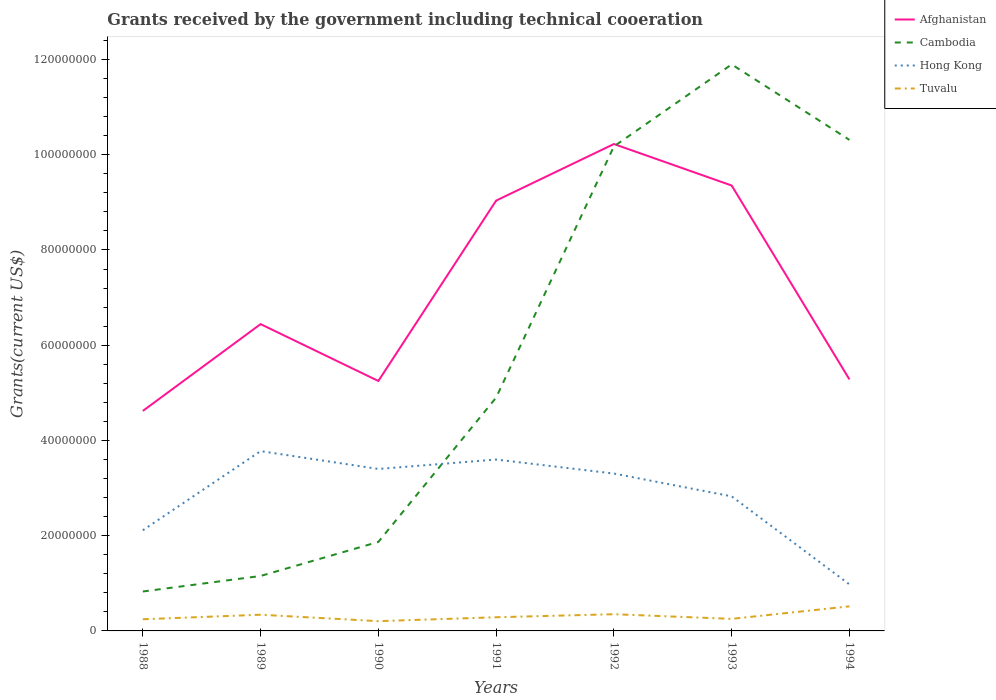How many different coloured lines are there?
Your response must be concise. 4. Does the line corresponding to Cambodia intersect with the line corresponding to Hong Kong?
Give a very brief answer. Yes. Across all years, what is the maximum total grants received by the government in Tuvalu?
Provide a short and direct response. 2.05e+06. What is the total total grants received by the government in Tuvalu in the graph?
Ensure brevity in your answer.  9.80e+05. What is the difference between the highest and the second highest total grants received by the government in Cambodia?
Your answer should be compact. 1.11e+08. Is the total grants received by the government in Tuvalu strictly greater than the total grants received by the government in Cambodia over the years?
Your response must be concise. Yes. How many lines are there?
Your answer should be compact. 4. Are the values on the major ticks of Y-axis written in scientific E-notation?
Offer a terse response. No. Where does the legend appear in the graph?
Give a very brief answer. Top right. How are the legend labels stacked?
Make the answer very short. Vertical. What is the title of the graph?
Offer a terse response. Grants received by the government including technical cooeration. Does "Oman" appear as one of the legend labels in the graph?
Your answer should be compact. No. What is the label or title of the Y-axis?
Ensure brevity in your answer.  Grants(current US$). What is the Grants(current US$) in Afghanistan in 1988?
Your answer should be very brief. 4.62e+07. What is the Grants(current US$) of Cambodia in 1988?
Offer a terse response. 8.28e+06. What is the Grants(current US$) in Hong Kong in 1988?
Your response must be concise. 2.11e+07. What is the Grants(current US$) in Tuvalu in 1988?
Give a very brief answer. 2.45e+06. What is the Grants(current US$) in Afghanistan in 1989?
Your response must be concise. 6.44e+07. What is the Grants(current US$) of Cambodia in 1989?
Give a very brief answer. 1.15e+07. What is the Grants(current US$) of Hong Kong in 1989?
Your answer should be compact. 3.78e+07. What is the Grants(current US$) in Tuvalu in 1989?
Provide a short and direct response. 3.40e+06. What is the Grants(current US$) of Afghanistan in 1990?
Give a very brief answer. 5.25e+07. What is the Grants(current US$) of Cambodia in 1990?
Provide a succinct answer. 1.87e+07. What is the Grants(current US$) of Hong Kong in 1990?
Offer a terse response. 3.40e+07. What is the Grants(current US$) of Tuvalu in 1990?
Offer a very short reply. 2.05e+06. What is the Grants(current US$) in Afghanistan in 1991?
Provide a succinct answer. 9.04e+07. What is the Grants(current US$) of Cambodia in 1991?
Your response must be concise. 4.90e+07. What is the Grants(current US$) in Hong Kong in 1991?
Provide a succinct answer. 3.60e+07. What is the Grants(current US$) of Tuvalu in 1991?
Your response must be concise. 2.87e+06. What is the Grants(current US$) in Afghanistan in 1992?
Give a very brief answer. 1.02e+08. What is the Grants(current US$) of Cambodia in 1992?
Give a very brief answer. 1.02e+08. What is the Grants(current US$) in Hong Kong in 1992?
Provide a short and direct response. 3.30e+07. What is the Grants(current US$) in Tuvalu in 1992?
Your response must be concise. 3.51e+06. What is the Grants(current US$) of Afghanistan in 1993?
Provide a short and direct response. 9.35e+07. What is the Grants(current US$) in Cambodia in 1993?
Your answer should be compact. 1.19e+08. What is the Grants(current US$) of Hong Kong in 1993?
Offer a terse response. 2.83e+07. What is the Grants(current US$) of Tuvalu in 1993?
Keep it short and to the point. 2.53e+06. What is the Grants(current US$) of Afghanistan in 1994?
Provide a succinct answer. 5.28e+07. What is the Grants(current US$) in Cambodia in 1994?
Make the answer very short. 1.03e+08. What is the Grants(current US$) in Hong Kong in 1994?
Give a very brief answer. 9.77e+06. What is the Grants(current US$) of Tuvalu in 1994?
Offer a very short reply. 5.16e+06. Across all years, what is the maximum Grants(current US$) of Afghanistan?
Your answer should be very brief. 1.02e+08. Across all years, what is the maximum Grants(current US$) of Cambodia?
Your response must be concise. 1.19e+08. Across all years, what is the maximum Grants(current US$) in Hong Kong?
Your answer should be compact. 3.78e+07. Across all years, what is the maximum Grants(current US$) in Tuvalu?
Your answer should be very brief. 5.16e+06. Across all years, what is the minimum Grants(current US$) of Afghanistan?
Provide a succinct answer. 4.62e+07. Across all years, what is the minimum Grants(current US$) in Cambodia?
Make the answer very short. 8.28e+06. Across all years, what is the minimum Grants(current US$) in Hong Kong?
Give a very brief answer. 9.77e+06. Across all years, what is the minimum Grants(current US$) of Tuvalu?
Your answer should be very brief. 2.05e+06. What is the total Grants(current US$) in Afghanistan in the graph?
Your answer should be compact. 5.02e+08. What is the total Grants(current US$) in Cambodia in the graph?
Your response must be concise. 4.11e+08. What is the total Grants(current US$) of Hong Kong in the graph?
Your answer should be very brief. 2.00e+08. What is the total Grants(current US$) of Tuvalu in the graph?
Your answer should be compact. 2.20e+07. What is the difference between the Grants(current US$) in Afghanistan in 1988 and that in 1989?
Keep it short and to the point. -1.82e+07. What is the difference between the Grants(current US$) of Cambodia in 1988 and that in 1989?
Offer a terse response. -3.26e+06. What is the difference between the Grants(current US$) of Hong Kong in 1988 and that in 1989?
Offer a very short reply. -1.66e+07. What is the difference between the Grants(current US$) in Tuvalu in 1988 and that in 1989?
Offer a very short reply. -9.50e+05. What is the difference between the Grants(current US$) in Afghanistan in 1988 and that in 1990?
Offer a terse response. -6.29e+06. What is the difference between the Grants(current US$) of Cambodia in 1988 and that in 1990?
Offer a terse response. -1.04e+07. What is the difference between the Grants(current US$) of Hong Kong in 1988 and that in 1990?
Your response must be concise. -1.29e+07. What is the difference between the Grants(current US$) in Tuvalu in 1988 and that in 1990?
Your response must be concise. 4.00e+05. What is the difference between the Grants(current US$) of Afghanistan in 1988 and that in 1991?
Your answer should be very brief. -4.42e+07. What is the difference between the Grants(current US$) of Cambodia in 1988 and that in 1991?
Your response must be concise. -4.07e+07. What is the difference between the Grants(current US$) of Hong Kong in 1988 and that in 1991?
Ensure brevity in your answer.  -1.48e+07. What is the difference between the Grants(current US$) of Tuvalu in 1988 and that in 1991?
Offer a terse response. -4.20e+05. What is the difference between the Grants(current US$) in Afghanistan in 1988 and that in 1992?
Ensure brevity in your answer.  -5.60e+07. What is the difference between the Grants(current US$) in Cambodia in 1988 and that in 1992?
Your response must be concise. -9.35e+07. What is the difference between the Grants(current US$) in Hong Kong in 1988 and that in 1992?
Give a very brief answer. -1.19e+07. What is the difference between the Grants(current US$) of Tuvalu in 1988 and that in 1992?
Your response must be concise. -1.06e+06. What is the difference between the Grants(current US$) of Afghanistan in 1988 and that in 1993?
Make the answer very short. -4.73e+07. What is the difference between the Grants(current US$) of Cambodia in 1988 and that in 1993?
Provide a succinct answer. -1.11e+08. What is the difference between the Grants(current US$) of Hong Kong in 1988 and that in 1993?
Provide a succinct answer. -7.12e+06. What is the difference between the Grants(current US$) in Afghanistan in 1988 and that in 1994?
Your response must be concise. -6.62e+06. What is the difference between the Grants(current US$) in Cambodia in 1988 and that in 1994?
Make the answer very short. -9.48e+07. What is the difference between the Grants(current US$) in Hong Kong in 1988 and that in 1994?
Keep it short and to the point. 1.14e+07. What is the difference between the Grants(current US$) of Tuvalu in 1988 and that in 1994?
Your answer should be compact. -2.71e+06. What is the difference between the Grants(current US$) in Afghanistan in 1989 and that in 1990?
Keep it short and to the point. 1.19e+07. What is the difference between the Grants(current US$) of Cambodia in 1989 and that in 1990?
Make the answer very short. -7.15e+06. What is the difference between the Grants(current US$) in Hong Kong in 1989 and that in 1990?
Provide a succinct answer. 3.75e+06. What is the difference between the Grants(current US$) of Tuvalu in 1989 and that in 1990?
Make the answer very short. 1.35e+06. What is the difference between the Grants(current US$) of Afghanistan in 1989 and that in 1991?
Make the answer very short. -2.59e+07. What is the difference between the Grants(current US$) in Cambodia in 1989 and that in 1991?
Your response must be concise. -3.75e+07. What is the difference between the Grants(current US$) of Hong Kong in 1989 and that in 1991?
Make the answer very short. 1.77e+06. What is the difference between the Grants(current US$) in Tuvalu in 1989 and that in 1991?
Provide a short and direct response. 5.30e+05. What is the difference between the Grants(current US$) of Afghanistan in 1989 and that in 1992?
Provide a succinct answer. -3.78e+07. What is the difference between the Grants(current US$) of Cambodia in 1989 and that in 1992?
Keep it short and to the point. -9.02e+07. What is the difference between the Grants(current US$) in Hong Kong in 1989 and that in 1992?
Keep it short and to the point. 4.71e+06. What is the difference between the Grants(current US$) of Afghanistan in 1989 and that in 1993?
Your answer should be very brief. -2.91e+07. What is the difference between the Grants(current US$) in Cambodia in 1989 and that in 1993?
Provide a short and direct response. -1.07e+08. What is the difference between the Grants(current US$) of Hong Kong in 1989 and that in 1993?
Provide a succinct answer. 9.50e+06. What is the difference between the Grants(current US$) of Tuvalu in 1989 and that in 1993?
Your answer should be very brief. 8.70e+05. What is the difference between the Grants(current US$) of Afghanistan in 1989 and that in 1994?
Your answer should be very brief. 1.16e+07. What is the difference between the Grants(current US$) in Cambodia in 1989 and that in 1994?
Provide a succinct answer. -9.16e+07. What is the difference between the Grants(current US$) of Hong Kong in 1989 and that in 1994?
Provide a succinct answer. 2.80e+07. What is the difference between the Grants(current US$) in Tuvalu in 1989 and that in 1994?
Your response must be concise. -1.76e+06. What is the difference between the Grants(current US$) of Afghanistan in 1990 and that in 1991?
Provide a short and direct response. -3.79e+07. What is the difference between the Grants(current US$) in Cambodia in 1990 and that in 1991?
Your answer should be very brief. -3.03e+07. What is the difference between the Grants(current US$) of Hong Kong in 1990 and that in 1991?
Your response must be concise. -1.98e+06. What is the difference between the Grants(current US$) in Tuvalu in 1990 and that in 1991?
Ensure brevity in your answer.  -8.20e+05. What is the difference between the Grants(current US$) of Afghanistan in 1990 and that in 1992?
Your answer should be compact. -4.98e+07. What is the difference between the Grants(current US$) of Cambodia in 1990 and that in 1992?
Your answer should be compact. -8.31e+07. What is the difference between the Grants(current US$) in Hong Kong in 1990 and that in 1992?
Give a very brief answer. 9.60e+05. What is the difference between the Grants(current US$) in Tuvalu in 1990 and that in 1992?
Your answer should be very brief. -1.46e+06. What is the difference between the Grants(current US$) in Afghanistan in 1990 and that in 1993?
Give a very brief answer. -4.10e+07. What is the difference between the Grants(current US$) of Cambodia in 1990 and that in 1993?
Your answer should be very brief. -1.00e+08. What is the difference between the Grants(current US$) of Hong Kong in 1990 and that in 1993?
Give a very brief answer. 5.75e+06. What is the difference between the Grants(current US$) of Tuvalu in 1990 and that in 1993?
Your response must be concise. -4.80e+05. What is the difference between the Grants(current US$) in Afghanistan in 1990 and that in 1994?
Your answer should be compact. -3.30e+05. What is the difference between the Grants(current US$) in Cambodia in 1990 and that in 1994?
Make the answer very short. -8.44e+07. What is the difference between the Grants(current US$) of Hong Kong in 1990 and that in 1994?
Your response must be concise. 2.42e+07. What is the difference between the Grants(current US$) of Tuvalu in 1990 and that in 1994?
Offer a terse response. -3.11e+06. What is the difference between the Grants(current US$) in Afghanistan in 1991 and that in 1992?
Ensure brevity in your answer.  -1.19e+07. What is the difference between the Grants(current US$) in Cambodia in 1991 and that in 1992?
Make the answer very short. -5.28e+07. What is the difference between the Grants(current US$) of Hong Kong in 1991 and that in 1992?
Your answer should be compact. 2.94e+06. What is the difference between the Grants(current US$) of Tuvalu in 1991 and that in 1992?
Give a very brief answer. -6.40e+05. What is the difference between the Grants(current US$) of Afghanistan in 1991 and that in 1993?
Provide a succinct answer. -3.17e+06. What is the difference between the Grants(current US$) of Cambodia in 1991 and that in 1993?
Offer a terse response. -7.00e+07. What is the difference between the Grants(current US$) in Hong Kong in 1991 and that in 1993?
Your response must be concise. 7.73e+06. What is the difference between the Grants(current US$) of Tuvalu in 1991 and that in 1993?
Your response must be concise. 3.40e+05. What is the difference between the Grants(current US$) of Afghanistan in 1991 and that in 1994?
Offer a very short reply. 3.76e+07. What is the difference between the Grants(current US$) in Cambodia in 1991 and that in 1994?
Your answer should be very brief. -5.41e+07. What is the difference between the Grants(current US$) of Hong Kong in 1991 and that in 1994?
Make the answer very short. 2.62e+07. What is the difference between the Grants(current US$) of Tuvalu in 1991 and that in 1994?
Provide a short and direct response. -2.29e+06. What is the difference between the Grants(current US$) of Afghanistan in 1992 and that in 1993?
Keep it short and to the point. 8.71e+06. What is the difference between the Grants(current US$) in Cambodia in 1992 and that in 1993?
Your answer should be very brief. -1.72e+07. What is the difference between the Grants(current US$) of Hong Kong in 1992 and that in 1993?
Make the answer very short. 4.79e+06. What is the difference between the Grants(current US$) in Tuvalu in 1992 and that in 1993?
Your response must be concise. 9.80e+05. What is the difference between the Grants(current US$) of Afghanistan in 1992 and that in 1994?
Provide a short and direct response. 4.94e+07. What is the difference between the Grants(current US$) in Cambodia in 1992 and that in 1994?
Your answer should be compact. -1.37e+06. What is the difference between the Grants(current US$) of Hong Kong in 1992 and that in 1994?
Ensure brevity in your answer.  2.33e+07. What is the difference between the Grants(current US$) in Tuvalu in 1992 and that in 1994?
Give a very brief answer. -1.65e+06. What is the difference between the Grants(current US$) in Afghanistan in 1993 and that in 1994?
Ensure brevity in your answer.  4.07e+07. What is the difference between the Grants(current US$) in Cambodia in 1993 and that in 1994?
Make the answer very short. 1.58e+07. What is the difference between the Grants(current US$) of Hong Kong in 1993 and that in 1994?
Ensure brevity in your answer.  1.85e+07. What is the difference between the Grants(current US$) of Tuvalu in 1993 and that in 1994?
Give a very brief answer. -2.63e+06. What is the difference between the Grants(current US$) of Afghanistan in 1988 and the Grants(current US$) of Cambodia in 1989?
Ensure brevity in your answer.  3.47e+07. What is the difference between the Grants(current US$) of Afghanistan in 1988 and the Grants(current US$) of Hong Kong in 1989?
Keep it short and to the point. 8.44e+06. What is the difference between the Grants(current US$) of Afghanistan in 1988 and the Grants(current US$) of Tuvalu in 1989?
Keep it short and to the point. 4.28e+07. What is the difference between the Grants(current US$) in Cambodia in 1988 and the Grants(current US$) in Hong Kong in 1989?
Provide a short and direct response. -2.95e+07. What is the difference between the Grants(current US$) of Cambodia in 1988 and the Grants(current US$) of Tuvalu in 1989?
Provide a short and direct response. 4.88e+06. What is the difference between the Grants(current US$) of Hong Kong in 1988 and the Grants(current US$) of Tuvalu in 1989?
Your answer should be very brief. 1.77e+07. What is the difference between the Grants(current US$) in Afghanistan in 1988 and the Grants(current US$) in Cambodia in 1990?
Provide a short and direct response. 2.75e+07. What is the difference between the Grants(current US$) of Afghanistan in 1988 and the Grants(current US$) of Hong Kong in 1990?
Your response must be concise. 1.22e+07. What is the difference between the Grants(current US$) in Afghanistan in 1988 and the Grants(current US$) in Tuvalu in 1990?
Your response must be concise. 4.42e+07. What is the difference between the Grants(current US$) of Cambodia in 1988 and the Grants(current US$) of Hong Kong in 1990?
Offer a terse response. -2.57e+07. What is the difference between the Grants(current US$) of Cambodia in 1988 and the Grants(current US$) of Tuvalu in 1990?
Provide a short and direct response. 6.23e+06. What is the difference between the Grants(current US$) in Hong Kong in 1988 and the Grants(current US$) in Tuvalu in 1990?
Your answer should be compact. 1.91e+07. What is the difference between the Grants(current US$) of Afghanistan in 1988 and the Grants(current US$) of Cambodia in 1991?
Provide a succinct answer. -2.80e+06. What is the difference between the Grants(current US$) in Afghanistan in 1988 and the Grants(current US$) in Hong Kong in 1991?
Ensure brevity in your answer.  1.02e+07. What is the difference between the Grants(current US$) in Afghanistan in 1988 and the Grants(current US$) in Tuvalu in 1991?
Offer a very short reply. 4.33e+07. What is the difference between the Grants(current US$) in Cambodia in 1988 and the Grants(current US$) in Hong Kong in 1991?
Provide a short and direct response. -2.77e+07. What is the difference between the Grants(current US$) of Cambodia in 1988 and the Grants(current US$) of Tuvalu in 1991?
Your response must be concise. 5.41e+06. What is the difference between the Grants(current US$) of Hong Kong in 1988 and the Grants(current US$) of Tuvalu in 1991?
Ensure brevity in your answer.  1.83e+07. What is the difference between the Grants(current US$) in Afghanistan in 1988 and the Grants(current US$) in Cambodia in 1992?
Offer a terse response. -5.56e+07. What is the difference between the Grants(current US$) in Afghanistan in 1988 and the Grants(current US$) in Hong Kong in 1992?
Make the answer very short. 1.32e+07. What is the difference between the Grants(current US$) in Afghanistan in 1988 and the Grants(current US$) in Tuvalu in 1992?
Offer a terse response. 4.27e+07. What is the difference between the Grants(current US$) in Cambodia in 1988 and the Grants(current US$) in Hong Kong in 1992?
Make the answer very short. -2.48e+07. What is the difference between the Grants(current US$) in Cambodia in 1988 and the Grants(current US$) in Tuvalu in 1992?
Provide a short and direct response. 4.77e+06. What is the difference between the Grants(current US$) of Hong Kong in 1988 and the Grants(current US$) of Tuvalu in 1992?
Provide a succinct answer. 1.76e+07. What is the difference between the Grants(current US$) in Afghanistan in 1988 and the Grants(current US$) in Cambodia in 1993?
Offer a terse response. -7.28e+07. What is the difference between the Grants(current US$) of Afghanistan in 1988 and the Grants(current US$) of Hong Kong in 1993?
Your answer should be compact. 1.79e+07. What is the difference between the Grants(current US$) in Afghanistan in 1988 and the Grants(current US$) in Tuvalu in 1993?
Your answer should be very brief. 4.37e+07. What is the difference between the Grants(current US$) of Cambodia in 1988 and the Grants(current US$) of Hong Kong in 1993?
Offer a very short reply. -2.00e+07. What is the difference between the Grants(current US$) in Cambodia in 1988 and the Grants(current US$) in Tuvalu in 1993?
Your answer should be compact. 5.75e+06. What is the difference between the Grants(current US$) in Hong Kong in 1988 and the Grants(current US$) in Tuvalu in 1993?
Your answer should be very brief. 1.86e+07. What is the difference between the Grants(current US$) of Afghanistan in 1988 and the Grants(current US$) of Cambodia in 1994?
Your answer should be very brief. -5.69e+07. What is the difference between the Grants(current US$) of Afghanistan in 1988 and the Grants(current US$) of Hong Kong in 1994?
Offer a very short reply. 3.64e+07. What is the difference between the Grants(current US$) in Afghanistan in 1988 and the Grants(current US$) in Tuvalu in 1994?
Offer a terse response. 4.10e+07. What is the difference between the Grants(current US$) of Cambodia in 1988 and the Grants(current US$) of Hong Kong in 1994?
Make the answer very short. -1.49e+06. What is the difference between the Grants(current US$) in Cambodia in 1988 and the Grants(current US$) in Tuvalu in 1994?
Give a very brief answer. 3.12e+06. What is the difference between the Grants(current US$) in Hong Kong in 1988 and the Grants(current US$) in Tuvalu in 1994?
Your answer should be very brief. 1.60e+07. What is the difference between the Grants(current US$) of Afghanistan in 1989 and the Grants(current US$) of Cambodia in 1990?
Offer a terse response. 4.57e+07. What is the difference between the Grants(current US$) in Afghanistan in 1989 and the Grants(current US$) in Hong Kong in 1990?
Ensure brevity in your answer.  3.04e+07. What is the difference between the Grants(current US$) in Afghanistan in 1989 and the Grants(current US$) in Tuvalu in 1990?
Provide a short and direct response. 6.24e+07. What is the difference between the Grants(current US$) of Cambodia in 1989 and the Grants(current US$) of Hong Kong in 1990?
Provide a short and direct response. -2.25e+07. What is the difference between the Grants(current US$) in Cambodia in 1989 and the Grants(current US$) in Tuvalu in 1990?
Provide a succinct answer. 9.49e+06. What is the difference between the Grants(current US$) in Hong Kong in 1989 and the Grants(current US$) in Tuvalu in 1990?
Ensure brevity in your answer.  3.57e+07. What is the difference between the Grants(current US$) in Afghanistan in 1989 and the Grants(current US$) in Cambodia in 1991?
Make the answer very short. 1.54e+07. What is the difference between the Grants(current US$) in Afghanistan in 1989 and the Grants(current US$) in Hong Kong in 1991?
Make the answer very short. 2.84e+07. What is the difference between the Grants(current US$) in Afghanistan in 1989 and the Grants(current US$) in Tuvalu in 1991?
Make the answer very short. 6.16e+07. What is the difference between the Grants(current US$) of Cambodia in 1989 and the Grants(current US$) of Hong Kong in 1991?
Give a very brief answer. -2.44e+07. What is the difference between the Grants(current US$) of Cambodia in 1989 and the Grants(current US$) of Tuvalu in 1991?
Keep it short and to the point. 8.67e+06. What is the difference between the Grants(current US$) of Hong Kong in 1989 and the Grants(current US$) of Tuvalu in 1991?
Give a very brief answer. 3.49e+07. What is the difference between the Grants(current US$) of Afghanistan in 1989 and the Grants(current US$) of Cambodia in 1992?
Provide a succinct answer. -3.73e+07. What is the difference between the Grants(current US$) in Afghanistan in 1989 and the Grants(current US$) in Hong Kong in 1992?
Provide a succinct answer. 3.14e+07. What is the difference between the Grants(current US$) in Afghanistan in 1989 and the Grants(current US$) in Tuvalu in 1992?
Your answer should be very brief. 6.09e+07. What is the difference between the Grants(current US$) in Cambodia in 1989 and the Grants(current US$) in Hong Kong in 1992?
Your answer should be very brief. -2.15e+07. What is the difference between the Grants(current US$) of Cambodia in 1989 and the Grants(current US$) of Tuvalu in 1992?
Keep it short and to the point. 8.03e+06. What is the difference between the Grants(current US$) of Hong Kong in 1989 and the Grants(current US$) of Tuvalu in 1992?
Your answer should be very brief. 3.42e+07. What is the difference between the Grants(current US$) of Afghanistan in 1989 and the Grants(current US$) of Cambodia in 1993?
Provide a short and direct response. -5.45e+07. What is the difference between the Grants(current US$) of Afghanistan in 1989 and the Grants(current US$) of Hong Kong in 1993?
Make the answer very short. 3.62e+07. What is the difference between the Grants(current US$) in Afghanistan in 1989 and the Grants(current US$) in Tuvalu in 1993?
Give a very brief answer. 6.19e+07. What is the difference between the Grants(current US$) in Cambodia in 1989 and the Grants(current US$) in Hong Kong in 1993?
Provide a short and direct response. -1.67e+07. What is the difference between the Grants(current US$) of Cambodia in 1989 and the Grants(current US$) of Tuvalu in 1993?
Keep it short and to the point. 9.01e+06. What is the difference between the Grants(current US$) of Hong Kong in 1989 and the Grants(current US$) of Tuvalu in 1993?
Make the answer very short. 3.52e+07. What is the difference between the Grants(current US$) in Afghanistan in 1989 and the Grants(current US$) in Cambodia in 1994?
Offer a terse response. -3.87e+07. What is the difference between the Grants(current US$) in Afghanistan in 1989 and the Grants(current US$) in Hong Kong in 1994?
Your answer should be very brief. 5.47e+07. What is the difference between the Grants(current US$) in Afghanistan in 1989 and the Grants(current US$) in Tuvalu in 1994?
Give a very brief answer. 5.93e+07. What is the difference between the Grants(current US$) in Cambodia in 1989 and the Grants(current US$) in Hong Kong in 1994?
Keep it short and to the point. 1.77e+06. What is the difference between the Grants(current US$) of Cambodia in 1989 and the Grants(current US$) of Tuvalu in 1994?
Make the answer very short. 6.38e+06. What is the difference between the Grants(current US$) in Hong Kong in 1989 and the Grants(current US$) in Tuvalu in 1994?
Give a very brief answer. 3.26e+07. What is the difference between the Grants(current US$) in Afghanistan in 1990 and the Grants(current US$) in Cambodia in 1991?
Offer a terse response. 3.49e+06. What is the difference between the Grants(current US$) in Afghanistan in 1990 and the Grants(current US$) in Hong Kong in 1991?
Offer a very short reply. 1.65e+07. What is the difference between the Grants(current US$) of Afghanistan in 1990 and the Grants(current US$) of Tuvalu in 1991?
Offer a terse response. 4.96e+07. What is the difference between the Grants(current US$) in Cambodia in 1990 and the Grants(current US$) in Hong Kong in 1991?
Make the answer very short. -1.73e+07. What is the difference between the Grants(current US$) in Cambodia in 1990 and the Grants(current US$) in Tuvalu in 1991?
Make the answer very short. 1.58e+07. What is the difference between the Grants(current US$) in Hong Kong in 1990 and the Grants(current US$) in Tuvalu in 1991?
Make the answer very short. 3.11e+07. What is the difference between the Grants(current US$) in Afghanistan in 1990 and the Grants(current US$) in Cambodia in 1992?
Give a very brief answer. -4.93e+07. What is the difference between the Grants(current US$) in Afghanistan in 1990 and the Grants(current US$) in Hong Kong in 1992?
Offer a terse response. 1.94e+07. What is the difference between the Grants(current US$) of Afghanistan in 1990 and the Grants(current US$) of Tuvalu in 1992?
Provide a succinct answer. 4.90e+07. What is the difference between the Grants(current US$) of Cambodia in 1990 and the Grants(current US$) of Hong Kong in 1992?
Ensure brevity in your answer.  -1.44e+07. What is the difference between the Grants(current US$) of Cambodia in 1990 and the Grants(current US$) of Tuvalu in 1992?
Make the answer very short. 1.52e+07. What is the difference between the Grants(current US$) of Hong Kong in 1990 and the Grants(current US$) of Tuvalu in 1992?
Offer a very short reply. 3.05e+07. What is the difference between the Grants(current US$) of Afghanistan in 1990 and the Grants(current US$) of Cambodia in 1993?
Keep it short and to the point. -6.65e+07. What is the difference between the Grants(current US$) of Afghanistan in 1990 and the Grants(current US$) of Hong Kong in 1993?
Offer a very short reply. 2.42e+07. What is the difference between the Grants(current US$) in Afghanistan in 1990 and the Grants(current US$) in Tuvalu in 1993?
Keep it short and to the point. 5.00e+07. What is the difference between the Grants(current US$) of Cambodia in 1990 and the Grants(current US$) of Hong Kong in 1993?
Offer a terse response. -9.57e+06. What is the difference between the Grants(current US$) of Cambodia in 1990 and the Grants(current US$) of Tuvalu in 1993?
Offer a terse response. 1.62e+07. What is the difference between the Grants(current US$) of Hong Kong in 1990 and the Grants(current US$) of Tuvalu in 1993?
Ensure brevity in your answer.  3.15e+07. What is the difference between the Grants(current US$) of Afghanistan in 1990 and the Grants(current US$) of Cambodia in 1994?
Your response must be concise. -5.06e+07. What is the difference between the Grants(current US$) of Afghanistan in 1990 and the Grants(current US$) of Hong Kong in 1994?
Offer a terse response. 4.27e+07. What is the difference between the Grants(current US$) in Afghanistan in 1990 and the Grants(current US$) in Tuvalu in 1994?
Offer a very short reply. 4.73e+07. What is the difference between the Grants(current US$) in Cambodia in 1990 and the Grants(current US$) in Hong Kong in 1994?
Your answer should be very brief. 8.92e+06. What is the difference between the Grants(current US$) in Cambodia in 1990 and the Grants(current US$) in Tuvalu in 1994?
Provide a short and direct response. 1.35e+07. What is the difference between the Grants(current US$) of Hong Kong in 1990 and the Grants(current US$) of Tuvalu in 1994?
Keep it short and to the point. 2.88e+07. What is the difference between the Grants(current US$) in Afghanistan in 1991 and the Grants(current US$) in Cambodia in 1992?
Your response must be concise. -1.14e+07. What is the difference between the Grants(current US$) in Afghanistan in 1991 and the Grants(current US$) in Hong Kong in 1992?
Offer a very short reply. 5.73e+07. What is the difference between the Grants(current US$) of Afghanistan in 1991 and the Grants(current US$) of Tuvalu in 1992?
Offer a terse response. 8.69e+07. What is the difference between the Grants(current US$) of Cambodia in 1991 and the Grants(current US$) of Hong Kong in 1992?
Make the answer very short. 1.60e+07. What is the difference between the Grants(current US$) of Cambodia in 1991 and the Grants(current US$) of Tuvalu in 1992?
Your answer should be compact. 4.55e+07. What is the difference between the Grants(current US$) in Hong Kong in 1991 and the Grants(current US$) in Tuvalu in 1992?
Offer a terse response. 3.25e+07. What is the difference between the Grants(current US$) of Afghanistan in 1991 and the Grants(current US$) of Cambodia in 1993?
Ensure brevity in your answer.  -2.86e+07. What is the difference between the Grants(current US$) of Afghanistan in 1991 and the Grants(current US$) of Hong Kong in 1993?
Make the answer very short. 6.21e+07. What is the difference between the Grants(current US$) in Afghanistan in 1991 and the Grants(current US$) in Tuvalu in 1993?
Offer a terse response. 8.78e+07. What is the difference between the Grants(current US$) of Cambodia in 1991 and the Grants(current US$) of Hong Kong in 1993?
Offer a very short reply. 2.07e+07. What is the difference between the Grants(current US$) in Cambodia in 1991 and the Grants(current US$) in Tuvalu in 1993?
Offer a very short reply. 4.65e+07. What is the difference between the Grants(current US$) of Hong Kong in 1991 and the Grants(current US$) of Tuvalu in 1993?
Make the answer very short. 3.35e+07. What is the difference between the Grants(current US$) in Afghanistan in 1991 and the Grants(current US$) in Cambodia in 1994?
Ensure brevity in your answer.  -1.28e+07. What is the difference between the Grants(current US$) in Afghanistan in 1991 and the Grants(current US$) in Hong Kong in 1994?
Offer a terse response. 8.06e+07. What is the difference between the Grants(current US$) in Afghanistan in 1991 and the Grants(current US$) in Tuvalu in 1994?
Offer a terse response. 8.52e+07. What is the difference between the Grants(current US$) of Cambodia in 1991 and the Grants(current US$) of Hong Kong in 1994?
Offer a very short reply. 3.92e+07. What is the difference between the Grants(current US$) of Cambodia in 1991 and the Grants(current US$) of Tuvalu in 1994?
Keep it short and to the point. 4.38e+07. What is the difference between the Grants(current US$) in Hong Kong in 1991 and the Grants(current US$) in Tuvalu in 1994?
Provide a succinct answer. 3.08e+07. What is the difference between the Grants(current US$) in Afghanistan in 1992 and the Grants(current US$) in Cambodia in 1993?
Your response must be concise. -1.67e+07. What is the difference between the Grants(current US$) in Afghanistan in 1992 and the Grants(current US$) in Hong Kong in 1993?
Keep it short and to the point. 7.40e+07. What is the difference between the Grants(current US$) of Afghanistan in 1992 and the Grants(current US$) of Tuvalu in 1993?
Provide a succinct answer. 9.97e+07. What is the difference between the Grants(current US$) of Cambodia in 1992 and the Grants(current US$) of Hong Kong in 1993?
Your answer should be compact. 7.35e+07. What is the difference between the Grants(current US$) of Cambodia in 1992 and the Grants(current US$) of Tuvalu in 1993?
Keep it short and to the point. 9.92e+07. What is the difference between the Grants(current US$) in Hong Kong in 1992 and the Grants(current US$) in Tuvalu in 1993?
Keep it short and to the point. 3.05e+07. What is the difference between the Grants(current US$) of Afghanistan in 1992 and the Grants(current US$) of Cambodia in 1994?
Provide a succinct answer. -8.70e+05. What is the difference between the Grants(current US$) of Afghanistan in 1992 and the Grants(current US$) of Hong Kong in 1994?
Your answer should be very brief. 9.25e+07. What is the difference between the Grants(current US$) in Afghanistan in 1992 and the Grants(current US$) in Tuvalu in 1994?
Your response must be concise. 9.71e+07. What is the difference between the Grants(current US$) in Cambodia in 1992 and the Grants(current US$) in Hong Kong in 1994?
Offer a very short reply. 9.20e+07. What is the difference between the Grants(current US$) in Cambodia in 1992 and the Grants(current US$) in Tuvalu in 1994?
Keep it short and to the point. 9.66e+07. What is the difference between the Grants(current US$) in Hong Kong in 1992 and the Grants(current US$) in Tuvalu in 1994?
Offer a terse response. 2.79e+07. What is the difference between the Grants(current US$) of Afghanistan in 1993 and the Grants(current US$) of Cambodia in 1994?
Give a very brief answer. -9.58e+06. What is the difference between the Grants(current US$) in Afghanistan in 1993 and the Grants(current US$) in Hong Kong in 1994?
Offer a very short reply. 8.38e+07. What is the difference between the Grants(current US$) in Afghanistan in 1993 and the Grants(current US$) in Tuvalu in 1994?
Your response must be concise. 8.84e+07. What is the difference between the Grants(current US$) of Cambodia in 1993 and the Grants(current US$) of Hong Kong in 1994?
Make the answer very short. 1.09e+08. What is the difference between the Grants(current US$) of Cambodia in 1993 and the Grants(current US$) of Tuvalu in 1994?
Give a very brief answer. 1.14e+08. What is the difference between the Grants(current US$) in Hong Kong in 1993 and the Grants(current US$) in Tuvalu in 1994?
Provide a short and direct response. 2.31e+07. What is the average Grants(current US$) in Afghanistan per year?
Offer a terse response. 7.17e+07. What is the average Grants(current US$) of Cambodia per year?
Offer a terse response. 5.88e+07. What is the average Grants(current US$) in Hong Kong per year?
Your answer should be very brief. 2.86e+07. What is the average Grants(current US$) in Tuvalu per year?
Keep it short and to the point. 3.14e+06. In the year 1988, what is the difference between the Grants(current US$) in Afghanistan and Grants(current US$) in Cambodia?
Give a very brief answer. 3.79e+07. In the year 1988, what is the difference between the Grants(current US$) in Afghanistan and Grants(current US$) in Hong Kong?
Give a very brief answer. 2.51e+07. In the year 1988, what is the difference between the Grants(current US$) in Afghanistan and Grants(current US$) in Tuvalu?
Your answer should be compact. 4.38e+07. In the year 1988, what is the difference between the Grants(current US$) of Cambodia and Grants(current US$) of Hong Kong?
Offer a very short reply. -1.29e+07. In the year 1988, what is the difference between the Grants(current US$) of Cambodia and Grants(current US$) of Tuvalu?
Provide a short and direct response. 5.83e+06. In the year 1988, what is the difference between the Grants(current US$) in Hong Kong and Grants(current US$) in Tuvalu?
Your answer should be compact. 1.87e+07. In the year 1989, what is the difference between the Grants(current US$) in Afghanistan and Grants(current US$) in Cambodia?
Offer a very short reply. 5.29e+07. In the year 1989, what is the difference between the Grants(current US$) of Afghanistan and Grants(current US$) of Hong Kong?
Offer a terse response. 2.67e+07. In the year 1989, what is the difference between the Grants(current US$) in Afghanistan and Grants(current US$) in Tuvalu?
Ensure brevity in your answer.  6.10e+07. In the year 1989, what is the difference between the Grants(current US$) in Cambodia and Grants(current US$) in Hong Kong?
Offer a very short reply. -2.62e+07. In the year 1989, what is the difference between the Grants(current US$) in Cambodia and Grants(current US$) in Tuvalu?
Your response must be concise. 8.14e+06. In the year 1989, what is the difference between the Grants(current US$) of Hong Kong and Grants(current US$) of Tuvalu?
Offer a terse response. 3.44e+07. In the year 1990, what is the difference between the Grants(current US$) in Afghanistan and Grants(current US$) in Cambodia?
Offer a terse response. 3.38e+07. In the year 1990, what is the difference between the Grants(current US$) of Afghanistan and Grants(current US$) of Hong Kong?
Your answer should be very brief. 1.85e+07. In the year 1990, what is the difference between the Grants(current US$) of Afghanistan and Grants(current US$) of Tuvalu?
Make the answer very short. 5.04e+07. In the year 1990, what is the difference between the Grants(current US$) in Cambodia and Grants(current US$) in Hong Kong?
Provide a short and direct response. -1.53e+07. In the year 1990, what is the difference between the Grants(current US$) in Cambodia and Grants(current US$) in Tuvalu?
Provide a short and direct response. 1.66e+07. In the year 1990, what is the difference between the Grants(current US$) in Hong Kong and Grants(current US$) in Tuvalu?
Keep it short and to the point. 3.20e+07. In the year 1991, what is the difference between the Grants(current US$) of Afghanistan and Grants(current US$) of Cambodia?
Your answer should be very brief. 4.14e+07. In the year 1991, what is the difference between the Grants(current US$) of Afghanistan and Grants(current US$) of Hong Kong?
Give a very brief answer. 5.44e+07. In the year 1991, what is the difference between the Grants(current US$) of Afghanistan and Grants(current US$) of Tuvalu?
Provide a succinct answer. 8.75e+07. In the year 1991, what is the difference between the Grants(current US$) in Cambodia and Grants(current US$) in Hong Kong?
Your response must be concise. 1.30e+07. In the year 1991, what is the difference between the Grants(current US$) of Cambodia and Grants(current US$) of Tuvalu?
Offer a very short reply. 4.61e+07. In the year 1991, what is the difference between the Grants(current US$) of Hong Kong and Grants(current US$) of Tuvalu?
Keep it short and to the point. 3.31e+07. In the year 1992, what is the difference between the Grants(current US$) in Afghanistan and Grants(current US$) in Hong Kong?
Your answer should be very brief. 6.92e+07. In the year 1992, what is the difference between the Grants(current US$) of Afghanistan and Grants(current US$) of Tuvalu?
Keep it short and to the point. 9.87e+07. In the year 1992, what is the difference between the Grants(current US$) of Cambodia and Grants(current US$) of Hong Kong?
Your answer should be very brief. 6.87e+07. In the year 1992, what is the difference between the Grants(current US$) in Cambodia and Grants(current US$) in Tuvalu?
Your answer should be very brief. 9.82e+07. In the year 1992, what is the difference between the Grants(current US$) of Hong Kong and Grants(current US$) of Tuvalu?
Your answer should be very brief. 2.95e+07. In the year 1993, what is the difference between the Grants(current US$) in Afghanistan and Grants(current US$) in Cambodia?
Offer a very short reply. -2.54e+07. In the year 1993, what is the difference between the Grants(current US$) in Afghanistan and Grants(current US$) in Hong Kong?
Keep it short and to the point. 6.53e+07. In the year 1993, what is the difference between the Grants(current US$) in Afghanistan and Grants(current US$) in Tuvalu?
Offer a very short reply. 9.10e+07. In the year 1993, what is the difference between the Grants(current US$) in Cambodia and Grants(current US$) in Hong Kong?
Offer a very short reply. 9.07e+07. In the year 1993, what is the difference between the Grants(current US$) of Cambodia and Grants(current US$) of Tuvalu?
Your answer should be very brief. 1.16e+08. In the year 1993, what is the difference between the Grants(current US$) of Hong Kong and Grants(current US$) of Tuvalu?
Provide a succinct answer. 2.57e+07. In the year 1994, what is the difference between the Grants(current US$) in Afghanistan and Grants(current US$) in Cambodia?
Provide a short and direct response. -5.03e+07. In the year 1994, what is the difference between the Grants(current US$) of Afghanistan and Grants(current US$) of Hong Kong?
Your answer should be compact. 4.30e+07. In the year 1994, what is the difference between the Grants(current US$) of Afghanistan and Grants(current US$) of Tuvalu?
Your response must be concise. 4.77e+07. In the year 1994, what is the difference between the Grants(current US$) of Cambodia and Grants(current US$) of Hong Kong?
Offer a terse response. 9.34e+07. In the year 1994, what is the difference between the Grants(current US$) of Cambodia and Grants(current US$) of Tuvalu?
Give a very brief answer. 9.80e+07. In the year 1994, what is the difference between the Grants(current US$) in Hong Kong and Grants(current US$) in Tuvalu?
Provide a succinct answer. 4.61e+06. What is the ratio of the Grants(current US$) in Afghanistan in 1988 to that in 1989?
Give a very brief answer. 0.72. What is the ratio of the Grants(current US$) of Cambodia in 1988 to that in 1989?
Make the answer very short. 0.72. What is the ratio of the Grants(current US$) of Hong Kong in 1988 to that in 1989?
Offer a very short reply. 0.56. What is the ratio of the Grants(current US$) of Tuvalu in 1988 to that in 1989?
Provide a succinct answer. 0.72. What is the ratio of the Grants(current US$) in Afghanistan in 1988 to that in 1990?
Your answer should be compact. 0.88. What is the ratio of the Grants(current US$) of Cambodia in 1988 to that in 1990?
Provide a short and direct response. 0.44. What is the ratio of the Grants(current US$) of Hong Kong in 1988 to that in 1990?
Provide a short and direct response. 0.62. What is the ratio of the Grants(current US$) in Tuvalu in 1988 to that in 1990?
Make the answer very short. 1.2. What is the ratio of the Grants(current US$) of Afghanistan in 1988 to that in 1991?
Your answer should be very brief. 0.51. What is the ratio of the Grants(current US$) in Cambodia in 1988 to that in 1991?
Give a very brief answer. 0.17. What is the ratio of the Grants(current US$) in Hong Kong in 1988 to that in 1991?
Keep it short and to the point. 0.59. What is the ratio of the Grants(current US$) in Tuvalu in 1988 to that in 1991?
Make the answer very short. 0.85. What is the ratio of the Grants(current US$) in Afghanistan in 1988 to that in 1992?
Your answer should be very brief. 0.45. What is the ratio of the Grants(current US$) of Cambodia in 1988 to that in 1992?
Provide a succinct answer. 0.08. What is the ratio of the Grants(current US$) of Hong Kong in 1988 to that in 1992?
Offer a very short reply. 0.64. What is the ratio of the Grants(current US$) in Tuvalu in 1988 to that in 1992?
Make the answer very short. 0.7. What is the ratio of the Grants(current US$) in Afghanistan in 1988 to that in 1993?
Give a very brief answer. 0.49. What is the ratio of the Grants(current US$) of Cambodia in 1988 to that in 1993?
Keep it short and to the point. 0.07. What is the ratio of the Grants(current US$) in Hong Kong in 1988 to that in 1993?
Give a very brief answer. 0.75. What is the ratio of the Grants(current US$) in Tuvalu in 1988 to that in 1993?
Provide a succinct answer. 0.97. What is the ratio of the Grants(current US$) in Afghanistan in 1988 to that in 1994?
Provide a succinct answer. 0.87. What is the ratio of the Grants(current US$) in Cambodia in 1988 to that in 1994?
Offer a very short reply. 0.08. What is the ratio of the Grants(current US$) in Hong Kong in 1988 to that in 1994?
Provide a short and direct response. 2.16. What is the ratio of the Grants(current US$) of Tuvalu in 1988 to that in 1994?
Provide a short and direct response. 0.47. What is the ratio of the Grants(current US$) of Afghanistan in 1989 to that in 1990?
Your answer should be very brief. 1.23. What is the ratio of the Grants(current US$) of Cambodia in 1989 to that in 1990?
Your answer should be very brief. 0.62. What is the ratio of the Grants(current US$) in Hong Kong in 1989 to that in 1990?
Offer a very short reply. 1.11. What is the ratio of the Grants(current US$) of Tuvalu in 1989 to that in 1990?
Ensure brevity in your answer.  1.66. What is the ratio of the Grants(current US$) of Afghanistan in 1989 to that in 1991?
Offer a very short reply. 0.71. What is the ratio of the Grants(current US$) of Cambodia in 1989 to that in 1991?
Give a very brief answer. 0.24. What is the ratio of the Grants(current US$) in Hong Kong in 1989 to that in 1991?
Your response must be concise. 1.05. What is the ratio of the Grants(current US$) of Tuvalu in 1989 to that in 1991?
Provide a succinct answer. 1.18. What is the ratio of the Grants(current US$) in Afghanistan in 1989 to that in 1992?
Ensure brevity in your answer.  0.63. What is the ratio of the Grants(current US$) of Cambodia in 1989 to that in 1992?
Provide a succinct answer. 0.11. What is the ratio of the Grants(current US$) in Hong Kong in 1989 to that in 1992?
Keep it short and to the point. 1.14. What is the ratio of the Grants(current US$) of Tuvalu in 1989 to that in 1992?
Your answer should be very brief. 0.97. What is the ratio of the Grants(current US$) in Afghanistan in 1989 to that in 1993?
Provide a short and direct response. 0.69. What is the ratio of the Grants(current US$) of Cambodia in 1989 to that in 1993?
Your answer should be very brief. 0.1. What is the ratio of the Grants(current US$) in Hong Kong in 1989 to that in 1993?
Your response must be concise. 1.34. What is the ratio of the Grants(current US$) in Tuvalu in 1989 to that in 1993?
Your response must be concise. 1.34. What is the ratio of the Grants(current US$) of Afghanistan in 1989 to that in 1994?
Make the answer very short. 1.22. What is the ratio of the Grants(current US$) in Cambodia in 1989 to that in 1994?
Your response must be concise. 0.11. What is the ratio of the Grants(current US$) in Hong Kong in 1989 to that in 1994?
Provide a succinct answer. 3.86. What is the ratio of the Grants(current US$) in Tuvalu in 1989 to that in 1994?
Your answer should be compact. 0.66. What is the ratio of the Grants(current US$) of Afghanistan in 1990 to that in 1991?
Provide a succinct answer. 0.58. What is the ratio of the Grants(current US$) in Cambodia in 1990 to that in 1991?
Offer a terse response. 0.38. What is the ratio of the Grants(current US$) in Hong Kong in 1990 to that in 1991?
Ensure brevity in your answer.  0.94. What is the ratio of the Grants(current US$) in Afghanistan in 1990 to that in 1992?
Ensure brevity in your answer.  0.51. What is the ratio of the Grants(current US$) of Cambodia in 1990 to that in 1992?
Offer a very short reply. 0.18. What is the ratio of the Grants(current US$) of Tuvalu in 1990 to that in 1992?
Give a very brief answer. 0.58. What is the ratio of the Grants(current US$) in Afghanistan in 1990 to that in 1993?
Keep it short and to the point. 0.56. What is the ratio of the Grants(current US$) in Cambodia in 1990 to that in 1993?
Offer a terse response. 0.16. What is the ratio of the Grants(current US$) in Hong Kong in 1990 to that in 1993?
Your response must be concise. 1.2. What is the ratio of the Grants(current US$) in Tuvalu in 1990 to that in 1993?
Your response must be concise. 0.81. What is the ratio of the Grants(current US$) of Cambodia in 1990 to that in 1994?
Provide a short and direct response. 0.18. What is the ratio of the Grants(current US$) of Hong Kong in 1990 to that in 1994?
Keep it short and to the point. 3.48. What is the ratio of the Grants(current US$) in Tuvalu in 1990 to that in 1994?
Ensure brevity in your answer.  0.4. What is the ratio of the Grants(current US$) of Afghanistan in 1991 to that in 1992?
Provide a short and direct response. 0.88. What is the ratio of the Grants(current US$) in Cambodia in 1991 to that in 1992?
Give a very brief answer. 0.48. What is the ratio of the Grants(current US$) of Hong Kong in 1991 to that in 1992?
Provide a succinct answer. 1.09. What is the ratio of the Grants(current US$) in Tuvalu in 1991 to that in 1992?
Your answer should be compact. 0.82. What is the ratio of the Grants(current US$) of Afghanistan in 1991 to that in 1993?
Make the answer very short. 0.97. What is the ratio of the Grants(current US$) of Cambodia in 1991 to that in 1993?
Give a very brief answer. 0.41. What is the ratio of the Grants(current US$) in Hong Kong in 1991 to that in 1993?
Your response must be concise. 1.27. What is the ratio of the Grants(current US$) in Tuvalu in 1991 to that in 1993?
Provide a succinct answer. 1.13. What is the ratio of the Grants(current US$) of Afghanistan in 1991 to that in 1994?
Your response must be concise. 1.71. What is the ratio of the Grants(current US$) in Cambodia in 1991 to that in 1994?
Provide a short and direct response. 0.48. What is the ratio of the Grants(current US$) of Hong Kong in 1991 to that in 1994?
Provide a succinct answer. 3.68. What is the ratio of the Grants(current US$) of Tuvalu in 1991 to that in 1994?
Keep it short and to the point. 0.56. What is the ratio of the Grants(current US$) in Afghanistan in 1992 to that in 1993?
Make the answer very short. 1.09. What is the ratio of the Grants(current US$) of Cambodia in 1992 to that in 1993?
Your response must be concise. 0.86. What is the ratio of the Grants(current US$) of Hong Kong in 1992 to that in 1993?
Provide a short and direct response. 1.17. What is the ratio of the Grants(current US$) of Tuvalu in 1992 to that in 1993?
Offer a very short reply. 1.39. What is the ratio of the Grants(current US$) in Afghanistan in 1992 to that in 1994?
Keep it short and to the point. 1.94. What is the ratio of the Grants(current US$) in Cambodia in 1992 to that in 1994?
Provide a succinct answer. 0.99. What is the ratio of the Grants(current US$) of Hong Kong in 1992 to that in 1994?
Make the answer very short. 3.38. What is the ratio of the Grants(current US$) in Tuvalu in 1992 to that in 1994?
Provide a short and direct response. 0.68. What is the ratio of the Grants(current US$) in Afghanistan in 1993 to that in 1994?
Your response must be concise. 1.77. What is the ratio of the Grants(current US$) of Cambodia in 1993 to that in 1994?
Make the answer very short. 1.15. What is the ratio of the Grants(current US$) in Hong Kong in 1993 to that in 1994?
Your response must be concise. 2.89. What is the ratio of the Grants(current US$) in Tuvalu in 1993 to that in 1994?
Offer a terse response. 0.49. What is the difference between the highest and the second highest Grants(current US$) of Afghanistan?
Make the answer very short. 8.71e+06. What is the difference between the highest and the second highest Grants(current US$) in Cambodia?
Provide a succinct answer. 1.58e+07. What is the difference between the highest and the second highest Grants(current US$) in Hong Kong?
Your answer should be compact. 1.77e+06. What is the difference between the highest and the second highest Grants(current US$) of Tuvalu?
Offer a very short reply. 1.65e+06. What is the difference between the highest and the lowest Grants(current US$) in Afghanistan?
Your answer should be compact. 5.60e+07. What is the difference between the highest and the lowest Grants(current US$) in Cambodia?
Your response must be concise. 1.11e+08. What is the difference between the highest and the lowest Grants(current US$) of Hong Kong?
Offer a terse response. 2.80e+07. What is the difference between the highest and the lowest Grants(current US$) in Tuvalu?
Your answer should be compact. 3.11e+06. 